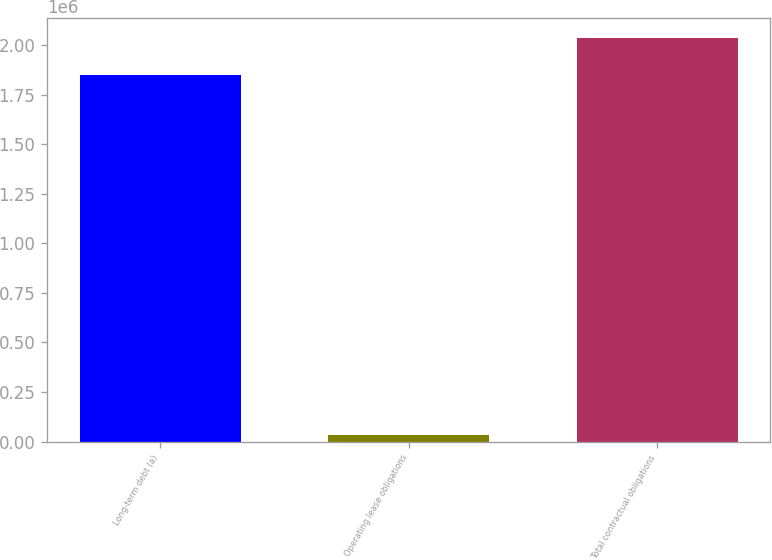<chart> <loc_0><loc_0><loc_500><loc_500><bar_chart><fcel>Long-term debt (a)<fcel>Operating lease obligations<fcel>Total contractual obligations<nl><fcel>1.85144e+06<fcel>34974<fcel>2.03658e+06<nl></chart> 